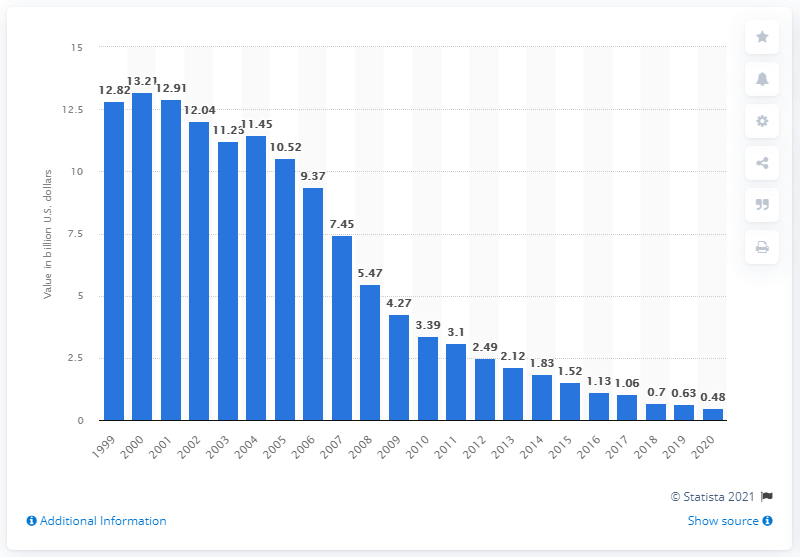List a handful of essential elements in this visual. The retail value of the 87.7 million CDs shipped in 2017 was 1.06 billion dollars. The estimated retail value of the 31.6 million physical albums shipped in 2020 was $0.48. 